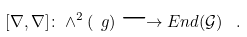Convert formula to latex. <formula><loc_0><loc_0><loc_500><loc_500>[ \nabla , \nabla ] \colon \wedge ^ { 2 } ( \ g ) \longrightarrow E n d ( { \mathcal { G } } ) \ \ .</formula> 